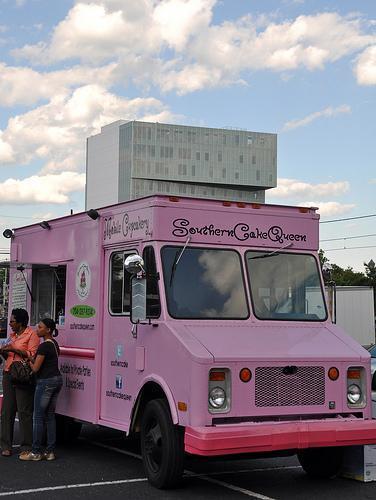How many people standing by the truck?
Give a very brief answer. 2. 